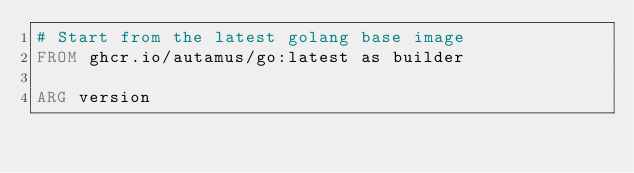<code> <loc_0><loc_0><loc_500><loc_500><_Dockerfile_># Start from the latest golang base image
FROM ghcr.io/autamus/go:latest as builder

ARG version
</code> 